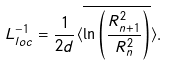Convert formula to latex. <formula><loc_0><loc_0><loc_500><loc_500>L _ { l o c } ^ { - 1 } = \frac { 1 } { 2 d } \langle \overline { \ln \left ( \frac { R ^ { 2 } _ { n + 1 } } { R ^ { 2 } _ { n } } \right ) } \rangle .</formula> 